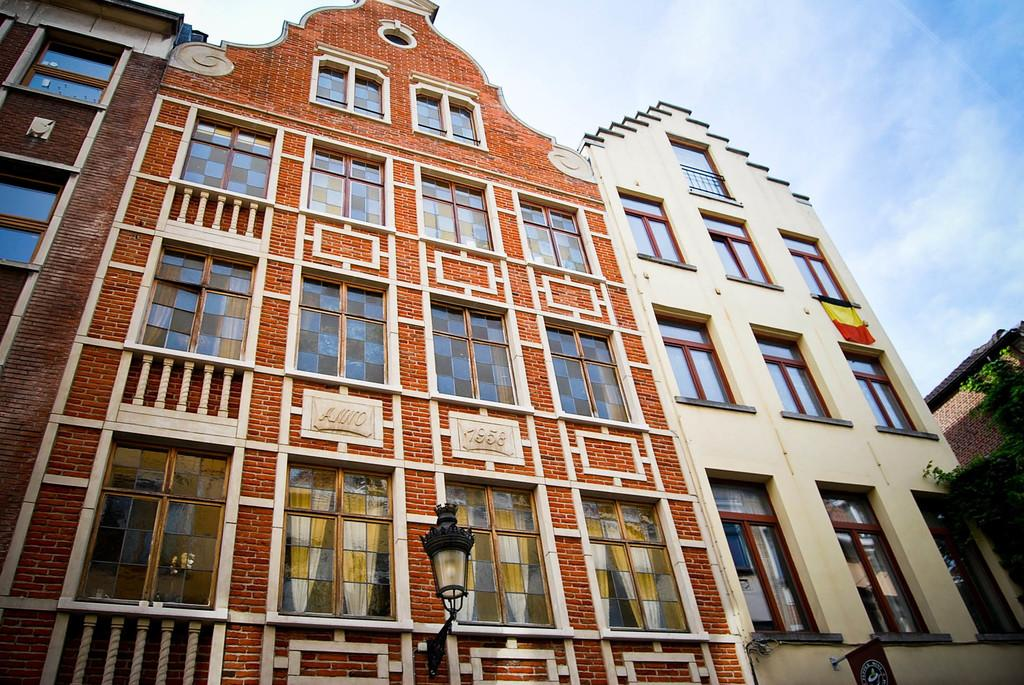What is the main structure in the middle of the image? There is a building in the middle of the image. What object can be found at the bottom of the image? There is a lamp in the bottom of the image. What part of the natural environment is visible in the image? The sky is visible at the top of the image. What type of collar can be seen on the building in the image? There is no collar present on the building in the image. What time of day is it in the image, based on the presence of a morning light? The provided facts do not mention the time of day or any specific lighting conditions, so it cannot be determined from the image. 